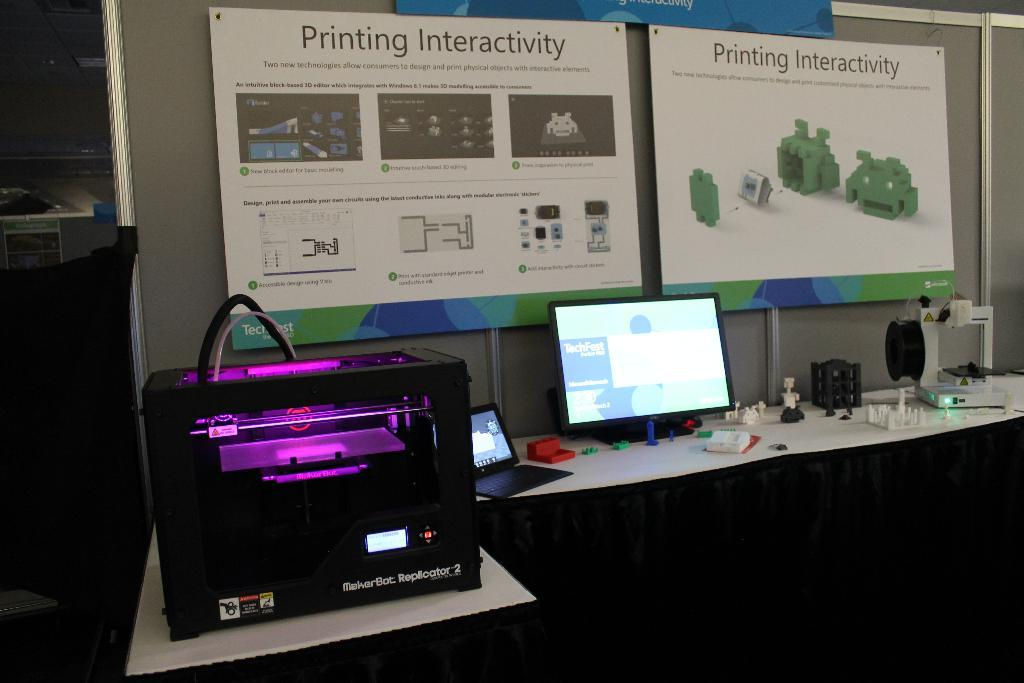Provide a one-sentence caption for the provided image. Standing at a desk set up with a printing interactivity event,with a large nice printer and computer. 